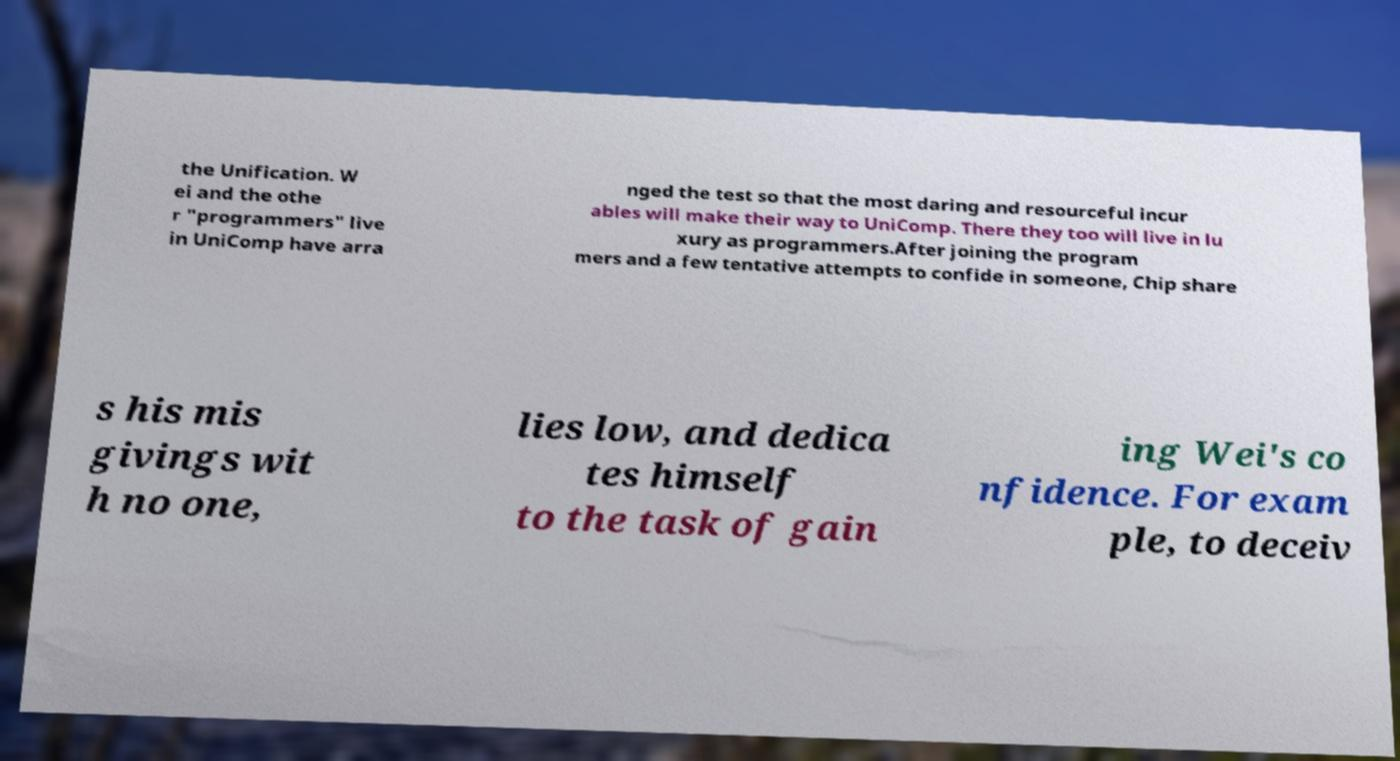Could you extract and type out the text from this image? the Unification. W ei and the othe r "programmers" live in UniComp have arra nged the test so that the most daring and resourceful incur ables will make their way to UniComp. There they too will live in lu xury as programmers.After joining the program mers and a few tentative attempts to confide in someone, Chip share s his mis givings wit h no one, lies low, and dedica tes himself to the task of gain ing Wei's co nfidence. For exam ple, to deceiv 